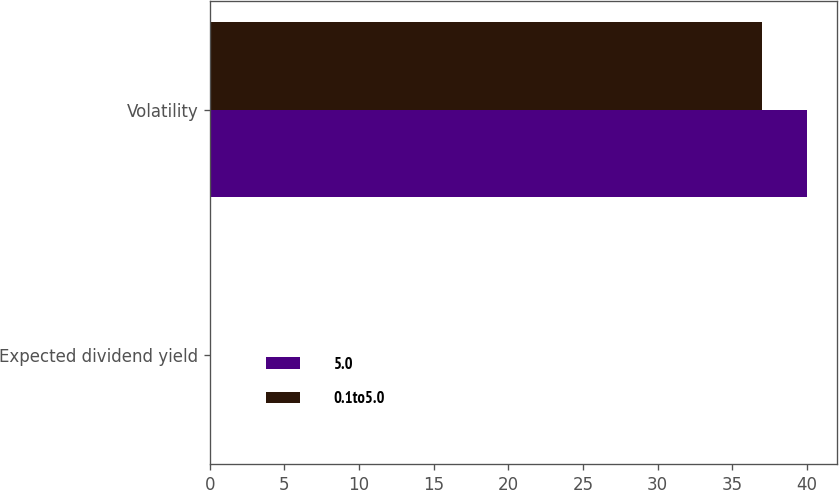Convert chart to OTSL. <chart><loc_0><loc_0><loc_500><loc_500><stacked_bar_chart><ecel><fcel>Expected dividend yield<fcel>Volatility<nl><fcel>5.0<fcel>0<fcel>40<nl><fcel>0.1to5.0<fcel>0<fcel>37<nl></chart> 